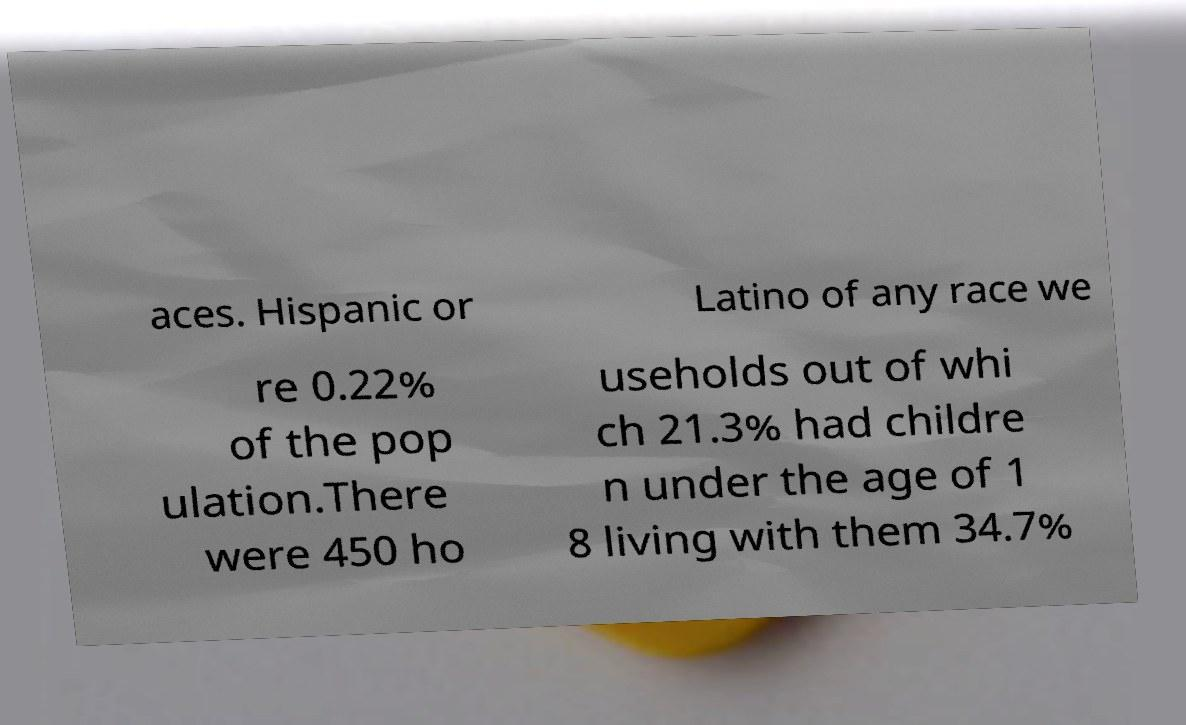Can you read and provide the text displayed in the image?This photo seems to have some interesting text. Can you extract and type it out for me? aces. Hispanic or Latino of any race we re 0.22% of the pop ulation.There were 450 ho useholds out of whi ch 21.3% had childre n under the age of 1 8 living with them 34.7% 